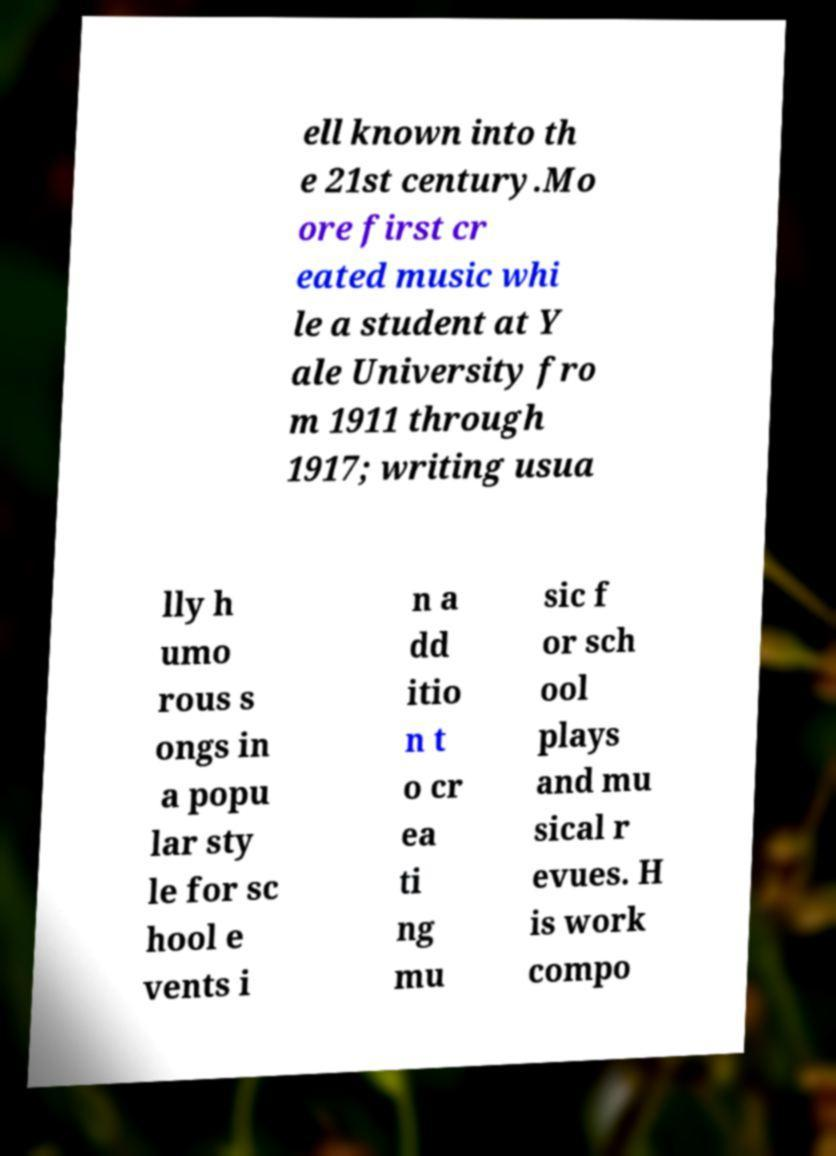I need the written content from this picture converted into text. Can you do that? ell known into th e 21st century.Mo ore first cr eated music whi le a student at Y ale University fro m 1911 through 1917; writing usua lly h umo rous s ongs in a popu lar sty le for sc hool e vents i n a dd itio n t o cr ea ti ng mu sic f or sch ool plays and mu sical r evues. H is work compo 